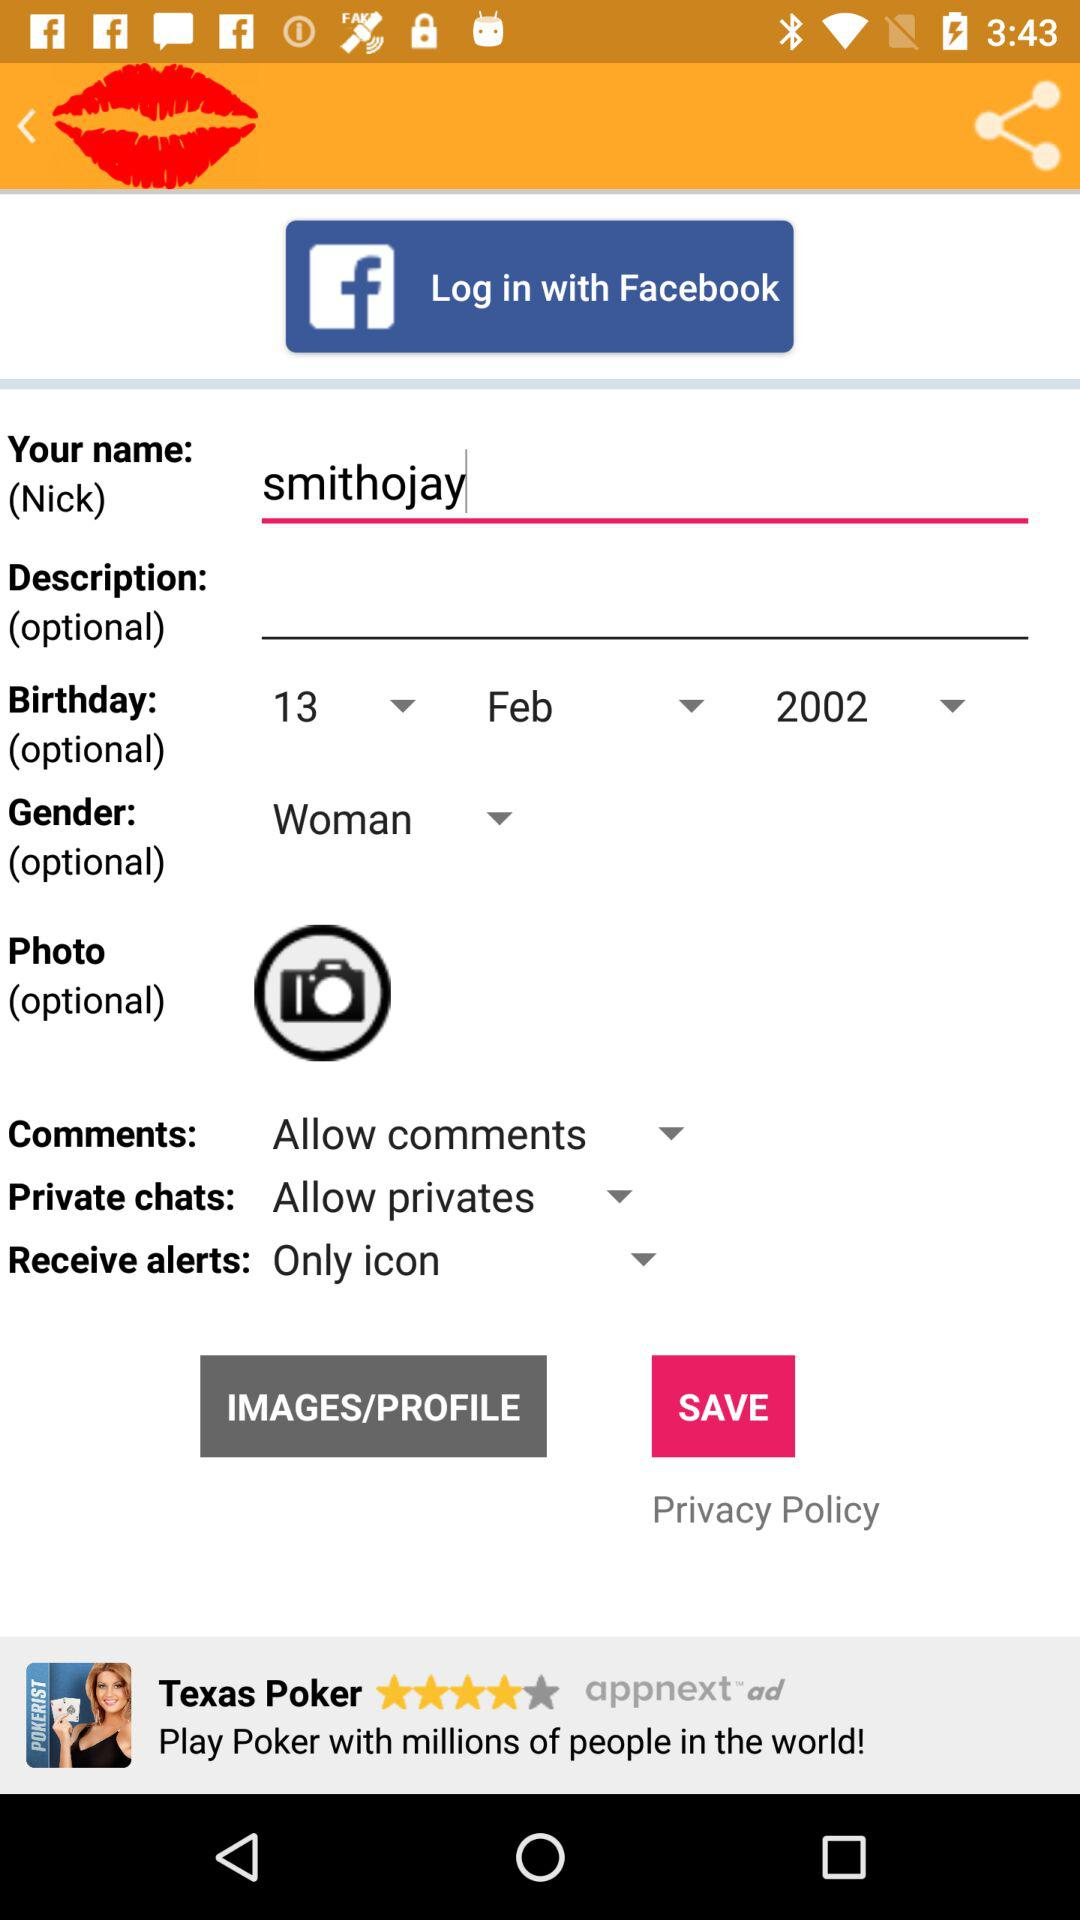What option is selected for "Receive alerts"? The selected option is "Only icon". 